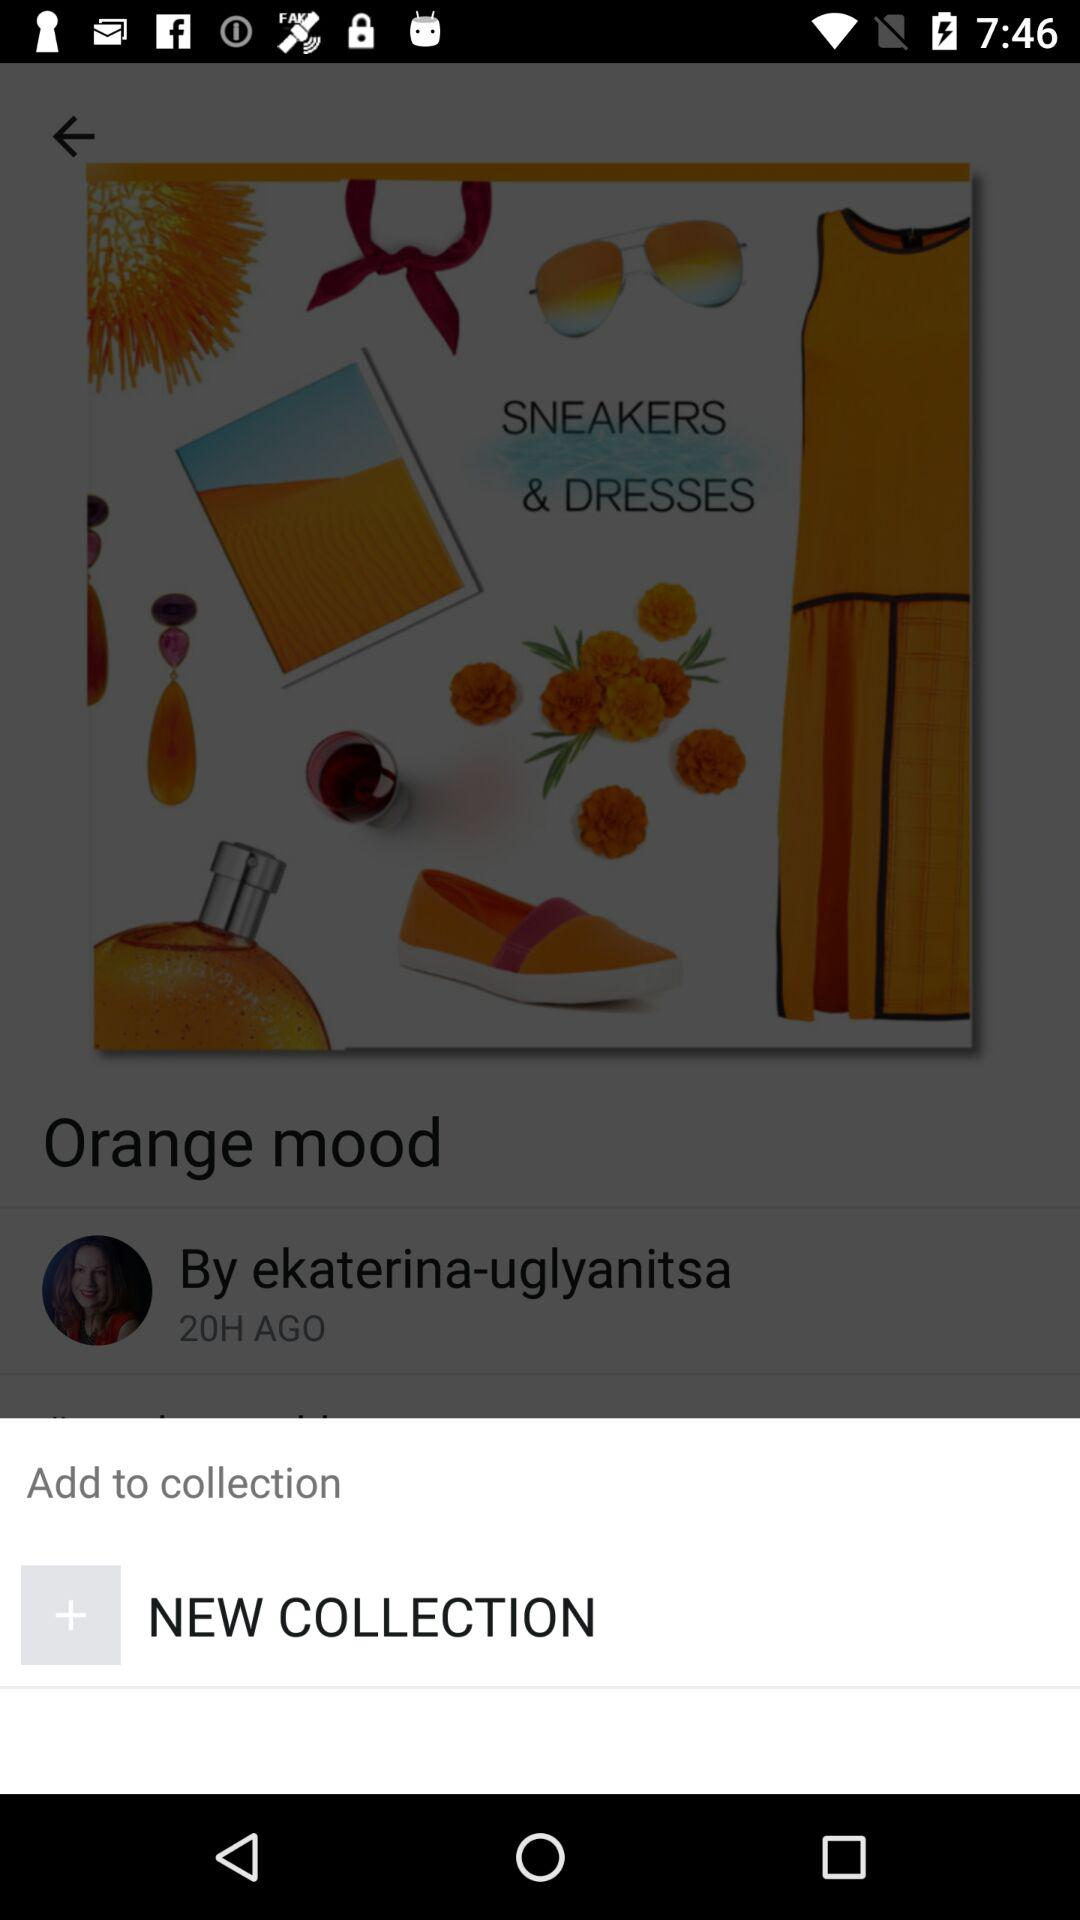What is the time duration?
When the provided information is insufficient, respond with <no answer>. <no answer> 